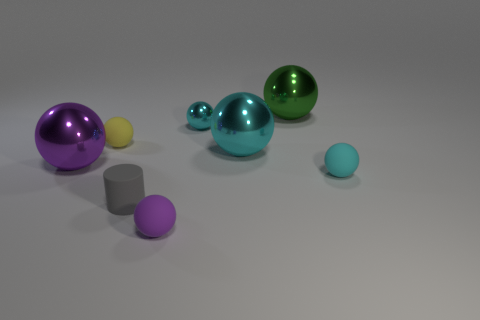Can you describe the colors of the spheres in the image? Certainly! In the image, there are spheres with several colors: one appears to be a shade of green, another looks cyan, and a third seems purple. There's also a smaller sphere with a much lighter, nearly pastel-like color. 